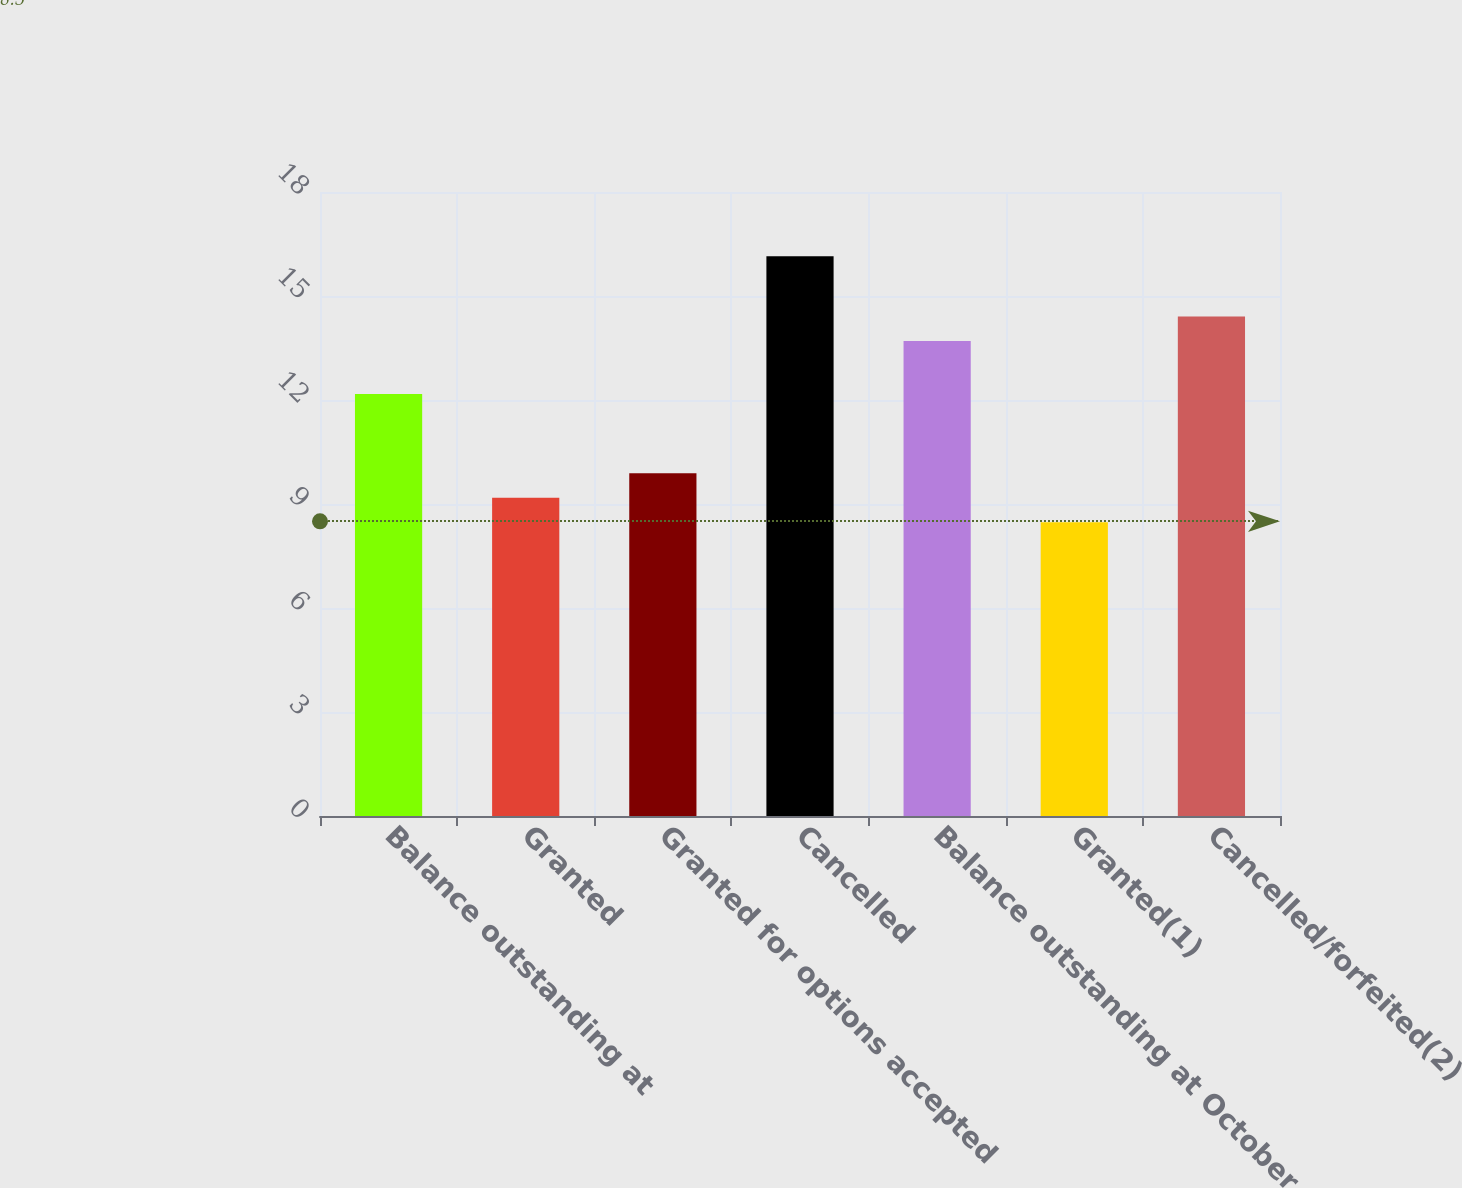Convert chart to OTSL. <chart><loc_0><loc_0><loc_500><loc_500><bar_chart><fcel>Balance outstanding at<fcel>Granted<fcel>Granted for options accepted<fcel>Cancelled<fcel>Balance outstanding at October<fcel>Granted(1)<fcel>Cancelled/forfeited(2)<nl><fcel>12.17<fcel>9.18<fcel>9.89<fcel>16.15<fcel>13.7<fcel>8.47<fcel>14.41<nl></chart> 